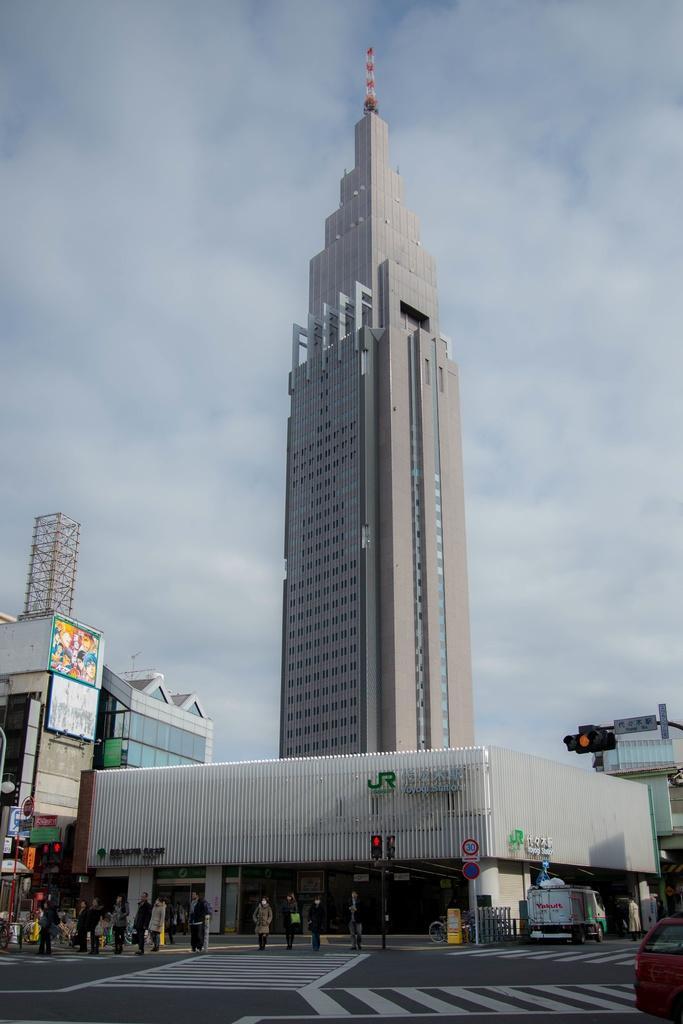How would you summarize this image in a sentence or two? In this picture I can see group of people standing, there are vehicles on the road, there are buildings, there are poles, boards, lights, and in the background there is the sky. 